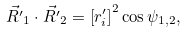Convert formula to latex. <formula><loc_0><loc_0><loc_500><loc_500>\vec { R ^ { \prime } } _ { 1 } \cdot \vec { R ^ { \prime } } _ { 2 } & = \left [ r ^ { \prime } _ { i } \right ] ^ { 2 } \cos \psi _ { 1 , 2 } ,</formula> 